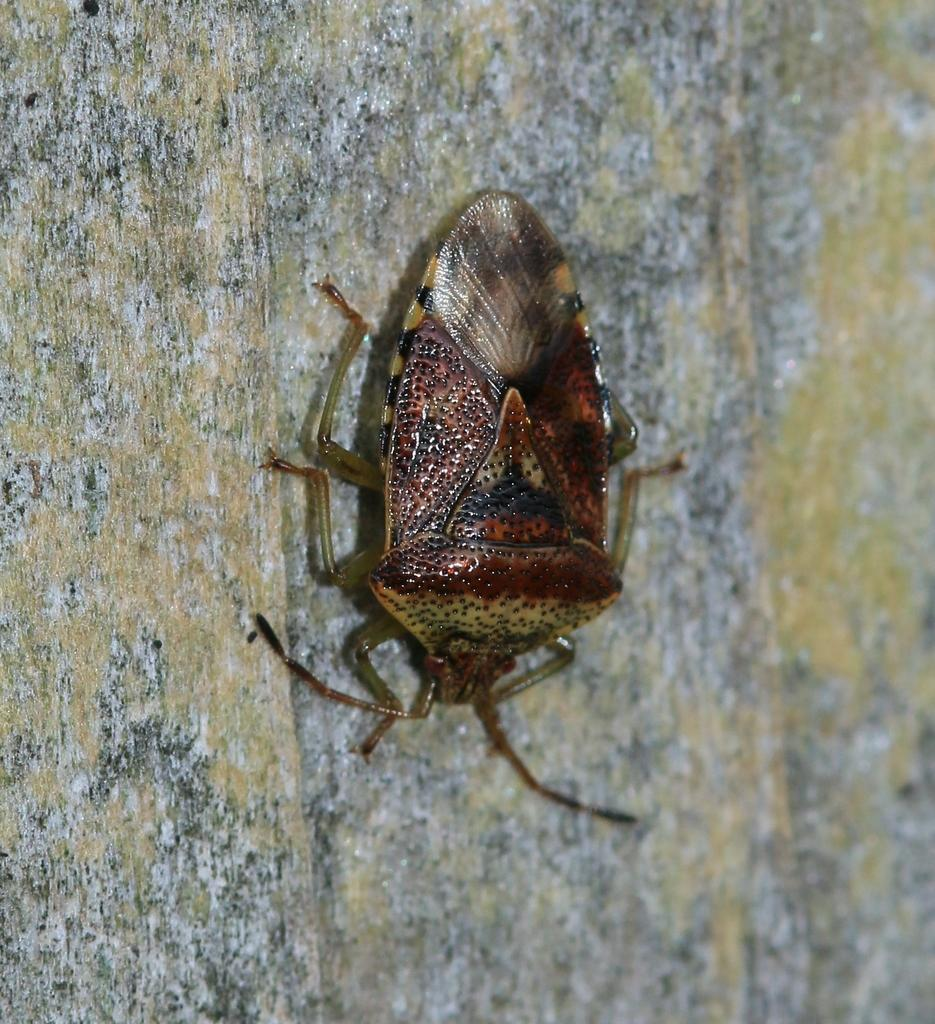What type of creature is present in the image? There is an insect in the image. Where is the insect located? The insect is on the wall. What type of board is the insect using to climb the wall in the image? There is no board present in the image, and the insect is not using any specific tool to climb the wall. 